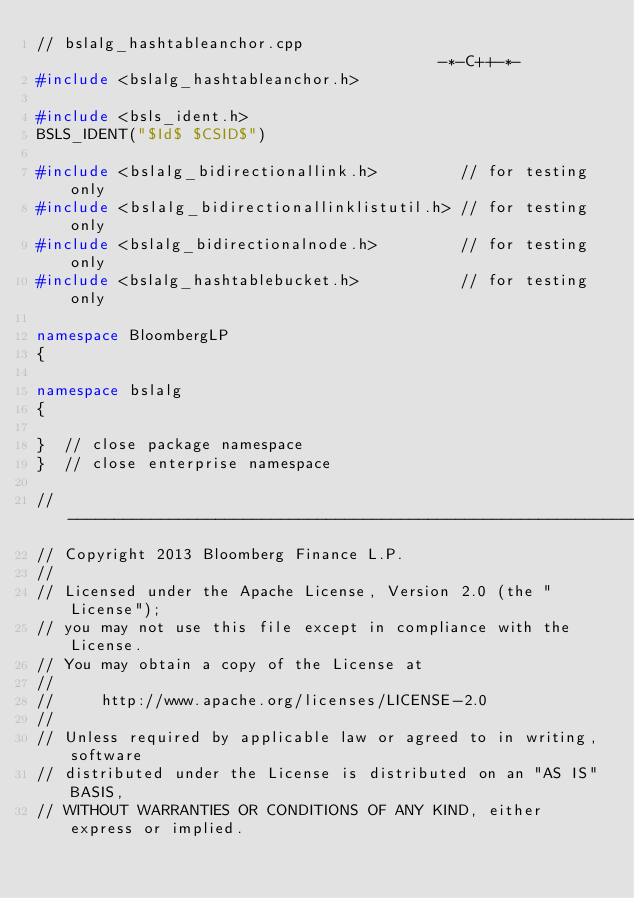Convert code to text. <code><loc_0><loc_0><loc_500><loc_500><_C++_>// bslalg_hashtableanchor.cpp                                         -*-C++-*-
#include <bslalg_hashtableanchor.h>

#include <bsls_ident.h>
BSLS_IDENT("$Id$ $CSID$")

#include <bslalg_bidirectionallink.h>         // for testing only
#include <bslalg_bidirectionallinklistutil.h> // for testing only
#include <bslalg_bidirectionalnode.h>         // for testing only
#include <bslalg_hashtablebucket.h>           // for testing only

namespace BloombergLP
{

namespace bslalg
{

}  // close package namespace
}  // close enterprise namespace

// ----------------------------------------------------------------------------
// Copyright 2013 Bloomberg Finance L.P.
//
// Licensed under the Apache License, Version 2.0 (the "License");
// you may not use this file except in compliance with the License.
// You may obtain a copy of the License at
//
//     http://www.apache.org/licenses/LICENSE-2.0
//
// Unless required by applicable law or agreed to in writing, software
// distributed under the License is distributed on an "AS IS" BASIS,
// WITHOUT WARRANTIES OR CONDITIONS OF ANY KIND, either express or implied.</code> 